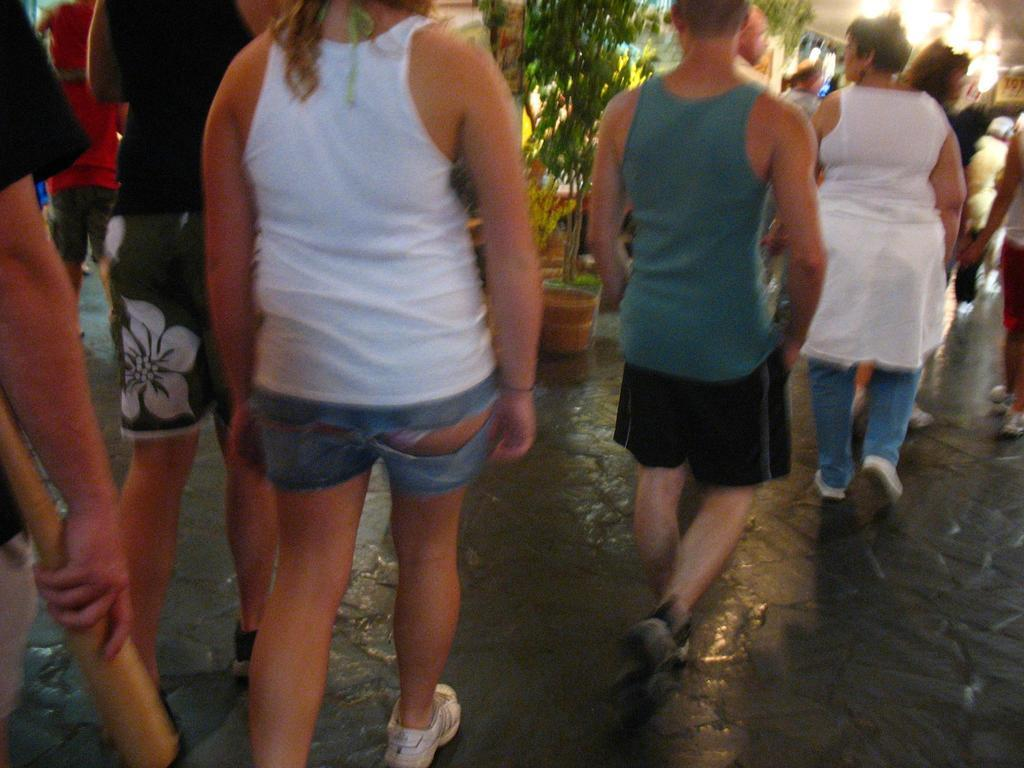What is happening with the group of people in the image? The people are walking in the image. What else can be seen in the image besides the group of people? There are plants and lights visible in the image. What type of wax is being used by the boys playing with toys in the image? There are no boys or toys present in the image, and therefore no wax is being used. 